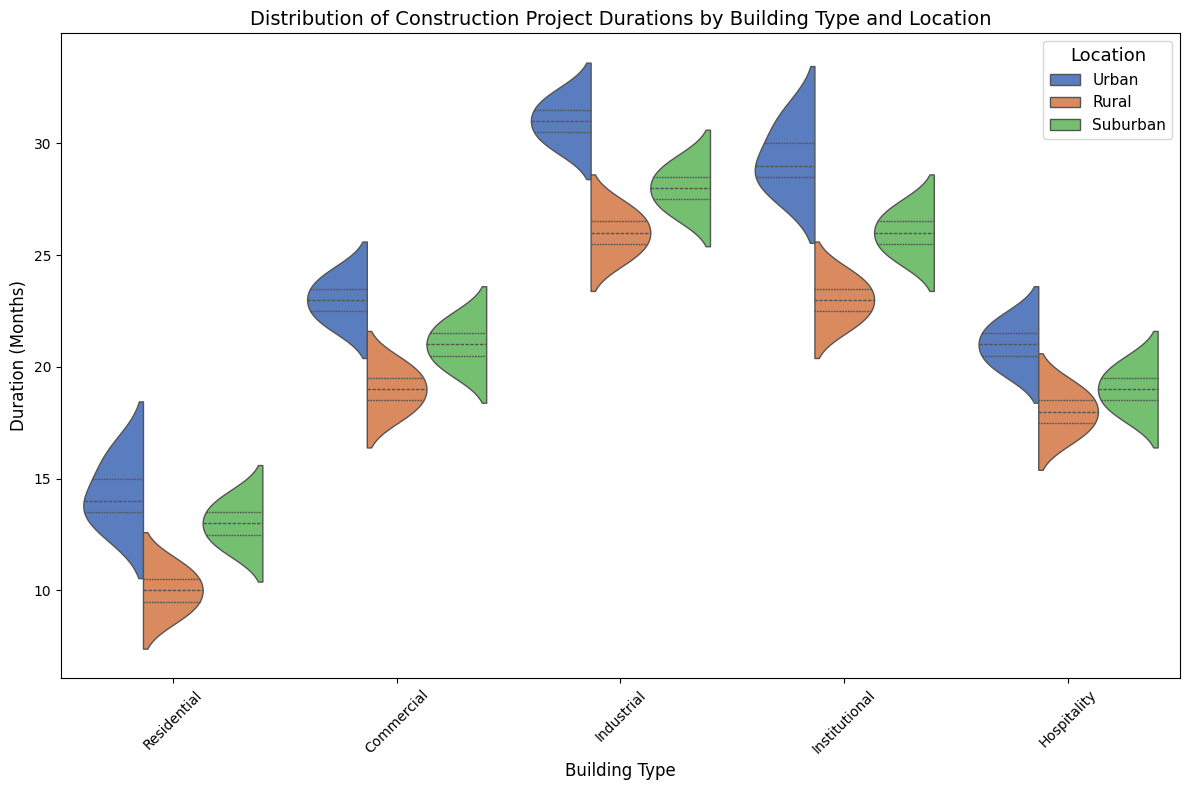What is the median duration for Urban Industrial projects? To get the median duration for Urban Industrial projects, find the middle value when the durations 30, 31, and 32 months are arranged in ascending order. The median is the middle value, which is 31.
Answer: 31 Which building type has the shortest median construction duration in Rural areas? Compare the medians of each building type in Rural areas. For Residential, the median is 10; for Commercial, the median is 19; for Industrial, the median is 26; for Institutional, the median is 23; for Hospitality, the median is 18. Therefore, Residential has the shortest median duration.
Answer: Residential Is there a significant difference in the median durations between Urban and Rural Hospitality projects? The median duration for Urban Hospitality projects is 21 months, while for Rural Hospitality projects, it is 18 months. The difference between the medians is 21 - 18 = 3 months.
Answer: 3 months Which location type shows the greatest variability in construction durations for Institutional buildings? By visually comparing the spread of the distributions for Institutional projects, Urban and Suburban locations have a similar spread, but Rural has a wider spread suggesting greater variability.
Answer: Rural Do Commercial projects in Suburban and Urban locations have similar duration distributions? Comparing the shapes of the violins, the duration distributions for both Suburban and Urban Commercial projects peak around similar values (20-24 months) and have similar spreads, indicating they are indeed similar.
Answer: Yes How does the average duration for Rural Residential projects compare to that of Urban Residential projects? Calculate the mean for each type: Rural Residential (9 + 10 + 11)/3 = 10; Urban Residential (13 + 14 + 16)/3 = 14.33. Comparing the two, Urban Residential has a higher average duration than Rural Residential.
Answer: Urban Residential higher For which building type is there the least difference in the median duration between Urban and Suburban locations? Identify the median durations for all building types in Urban and Suburban locations. The medians for Urban vs Suburban locations are: Residential (14 vs 13), Commercial (23 vs 21), Industrial (31 vs 28), Institutional (29 vs 26.5), Hospitality (21 vs 19). Residential has the smallest difference of 1 month.
Answer: Residential Is there any building type where Rural has a higher median duration than Urban? Compare the median durations for each building type in Urban and Rural locations. None of the Rural building types have a higher median duration than their Urban counterparts.
Answer: No Which building type and location combination has the longest median project duration? Examine the median durations for all combinations of building type and location. The longest median project duration is for Urban Industrial, which is 31 months.
Answer: Urban Industrial 